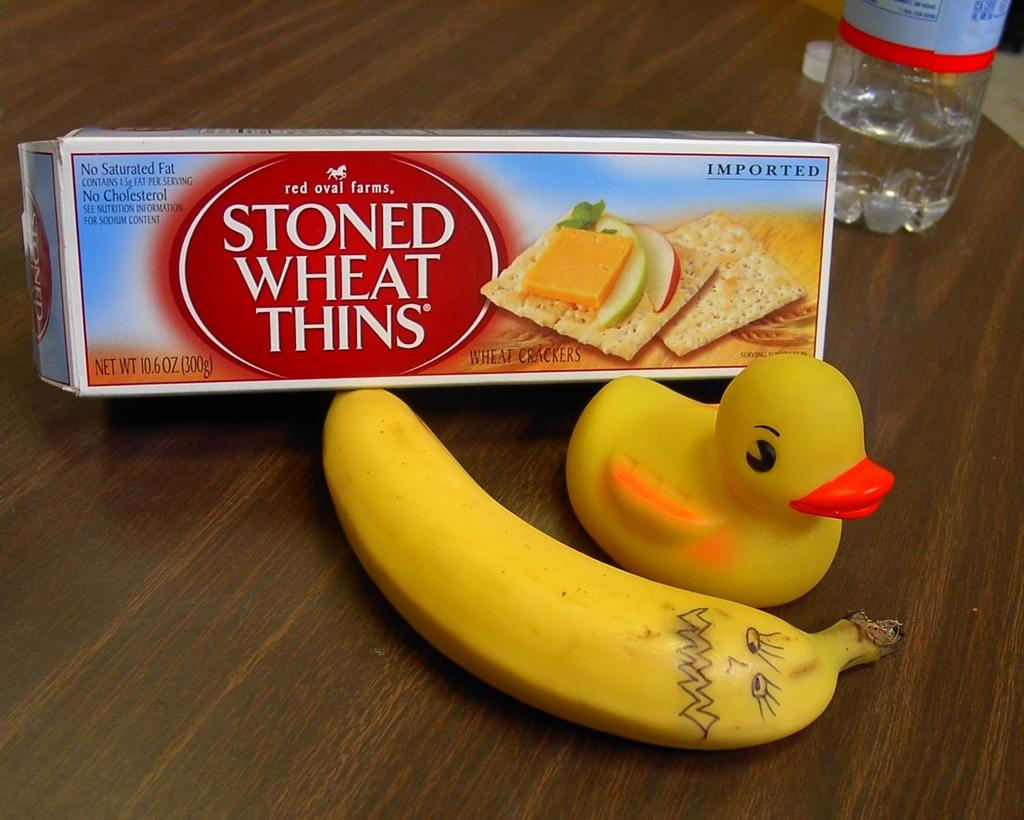What type of fruit is present in the image? There is a banana in the image. What kind of toy is visible in the image? There is a duck toy in the image. What food item is packaged in the image? There is a cheese packet in the image. What beverage container is present in the image? There is a water bottle in the image. Where are all the items located in the image? All items are on a table. Can you see the maid feeding the baby in the crib in the image? There is no maid or baby in a crib present in the image; it only contains a banana, duck toy, cheese packet, water bottle, and table. What is the duck toy doing with its tongue in the image? There is no tongue present on the duck toy in the image, as it is a toy and not a living creature. 